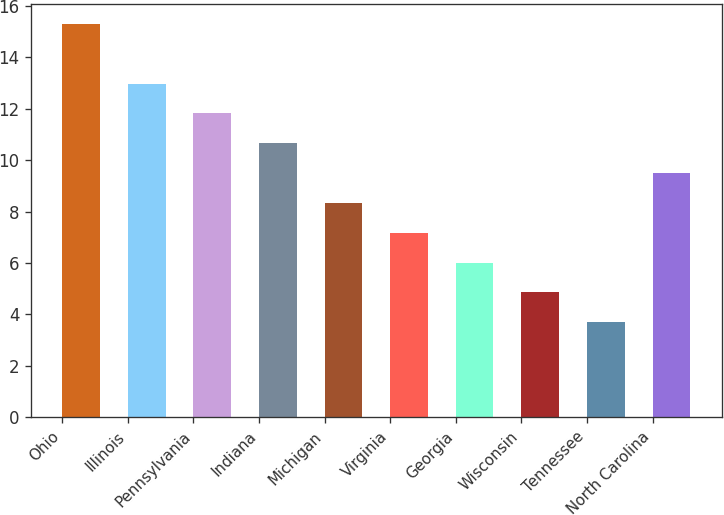Convert chart. <chart><loc_0><loc_0><loc_500><loc_500><bar_chart><fcel>Ohio<fcel>Illinois<fcel>Pennsylvania<fcel>Indiana<fcel>Michigan<fcel>Virginia<fcel>Georgia<fcel>Wisconsin<fcel>Tennessee<fcel>North Carolina<nl><fcel>15.3<fcel>12.98<fcel>11.82<fcel>10.66<fcel>8.34<fcel>7.18<fcel>6.02<fcel>4.86<fcel>3.7<fcel>9.5<nl></chart> 